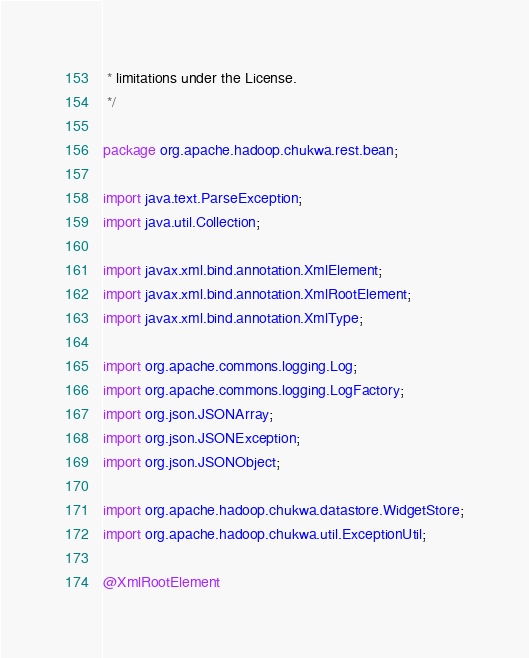Convert code to text. <code><loc_0><loc_0><loc_500><loc_500><_Java_> * limitations under the License.
 */

package org.apache.hadoop.chukwa.rest.bean;

import java.text.ParseException;
import java.util.Collection;

import javax.xml.bind.annotation.XmlElement;
import javax.xml.bind.annotation.XmlRootElement;
import javax.xml.bind.annotation.XmlType;

import org.apache.commons.logging.Log;
import org.apache.commons.logging.LogFactory;
import org.json.JSONArray;
import org.json.JSONException;
import org.json.JSONObject;

import org.apache.hadoop.chukwa.datastore.WidgetStore;
import org.apache.hadoop.chukwa.util.ExceptionUtil;

@XmlRootElement</code> 